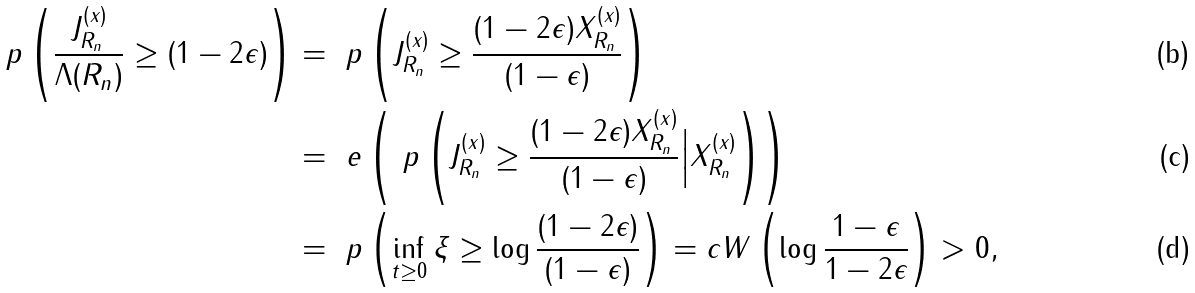<formula> <loc_0><loc_0><loc_500><loc_500>\ p \left ( \frac { J ^ { ( x ) } _ { R _ { n } } } { \Lambda ( R _ { n } ) } \geq ( 1 - 2 \epsilon ) \right ) & = \ p \left ( J ^ { ( x ) } _ { R _ { n } } \geq \frac { ( 1 - 2 \epsilon ) X ^ { ( x ) } _ { R _ { n } } } { ( 1 - \epsilon ) } \right ) \\ & = \ e \left ( \ p \left ( J ^ { ( x ) } _ { R _ { n } } \geq \frac { ( 1 - 2 \epsilon ) X ^ { ( x ) } _ { R _ { n } } } { ( 1 - \epsilon ) } \Big | X ^ { ( x ) } _ { R _ { n } } \right ) \right ) \\ & = \ p \left ( \inf _ { t \geq 0 } \xi \geq \log \frac { ( 1 - 2 \epsilon ) } { ( 1 - \epsilon ) } \right ) = c W \left ( \log \frac { 1 - \epsilon } { 1 - 2 \epsilon } \right ) > 0 ,</formula> 